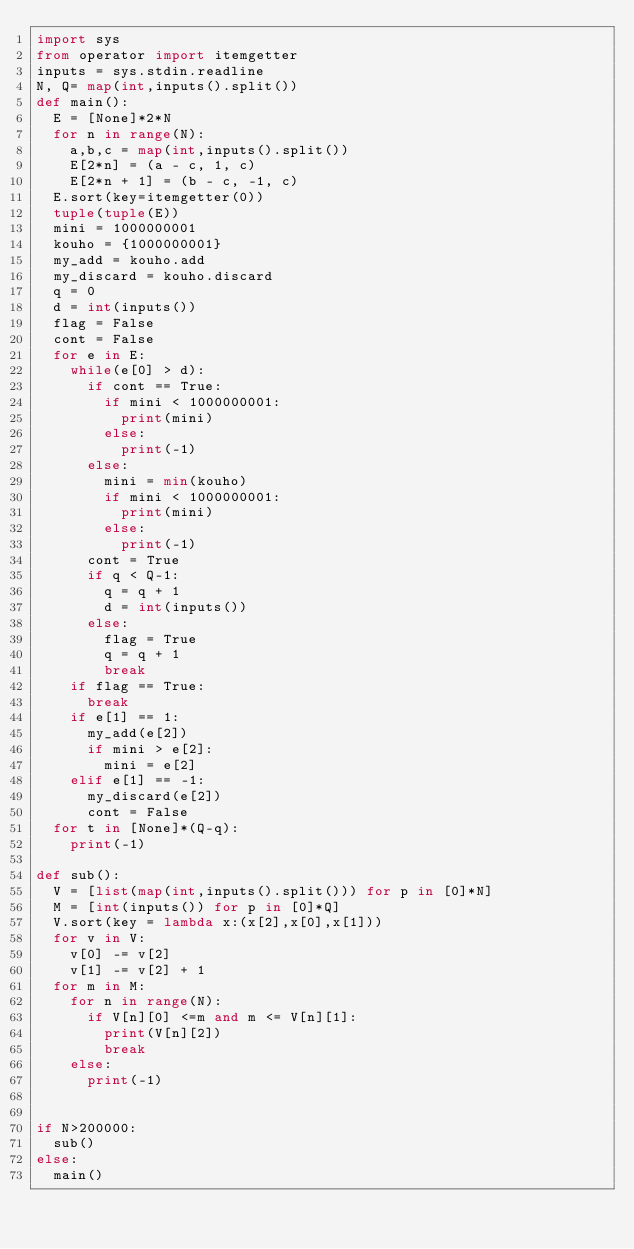Convert code to text. <code><loc_0><loc_0><loc_500><loc_500><_Python_>import sys
from operator import itemgetter
inputs = sys.stdin.readline
N, Q= map(int,inputs().split())
def main():
	E = [None]*2*N
	for n in range(N):
		a,b,c = map(int,inputs().split())
		E[2*n] = (a - c, 1, c)
		E[2*n + 1] = (b - c, -1, c)
	E.sort(key=itemgetter(0))
	tuple(tuple(E))
	mini = 1000000001
	kouho = {1000000001}
	my_add = kouho.add
	my_discard = kouho.discard
	q = 0
	d = int(inputs())
	flag = False
	cont = False
	for e in E:
		while(e[0] > d):
			if cont == True:
				if mini < 1000000001:
					print(mini)
				else:
					print(-1)
			else:
				mini = min(kouho)
				if mini < 1000000001:
					print(mini)
				else:
					print(-1)
			cont = True
			if q < Q-1:
				q = q + 1
				d = int(inputs())
			else:
				flag = True
				q = q + 1
				break
		if flag == True:
			break
		if e[1] == 1:
			my_add(e[2])
			if mini > e[2]:
				mini = e[2]
		elif e[1] == -1:
			my_discard(e[2])
			cont = False
	for t in [None]*(Q-q):
		print(-1)
		
def sub():
	V = [list(map(int,inputs().split())) for p in [0]*N]
	M = [int(inputs()) for p in [0]*Q]
	V.sort(key = lambda x:(x[2],x[0],x[1]))
	for v in V:
		v[0] -= v[2]
		v[1] -= v[2] + 1
	for m in M:
		for n in range(N):
			if V[n][0] <=m and m <= V[n][1]:
				print(V[n][2])
				break
		else:
			print(-1)


if N>200000:
	sub()
else:
	main()</code> 